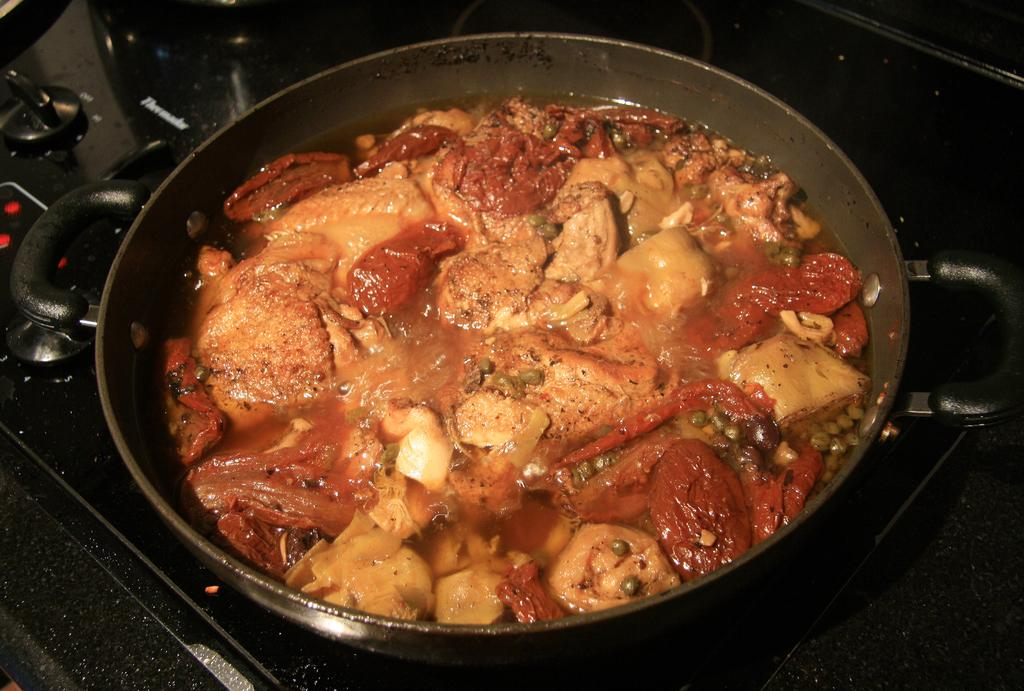What is in the bowl that is visible in the image? There is a bowl with food items in the image. Where is the bowl located in the image? The bowl is placed on a gas stove. What type of earth can be seen in the image? There is no earth visible in the image; it features a bowl with food items placed on a gas stove. 